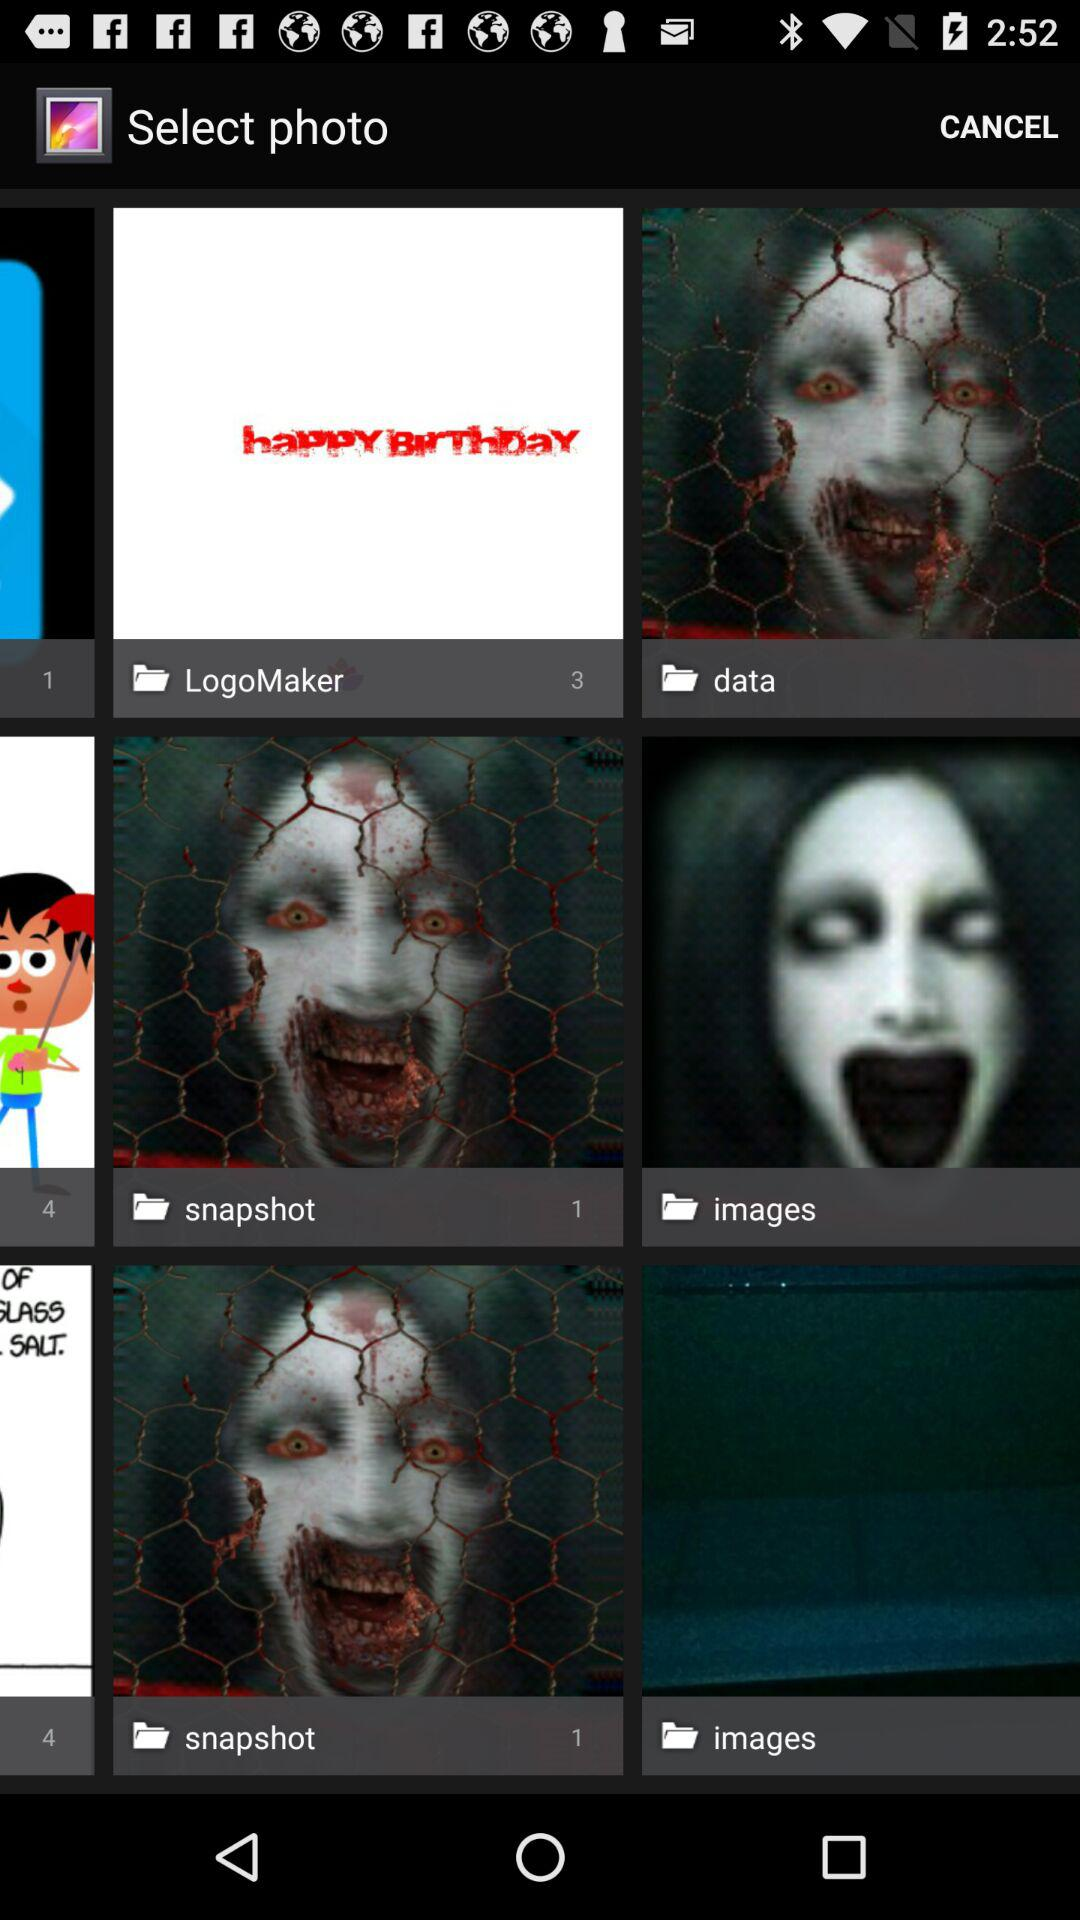How many photos are there in total in data?
When the provided information is insufficient, respond with <no answer>. <no answer> 